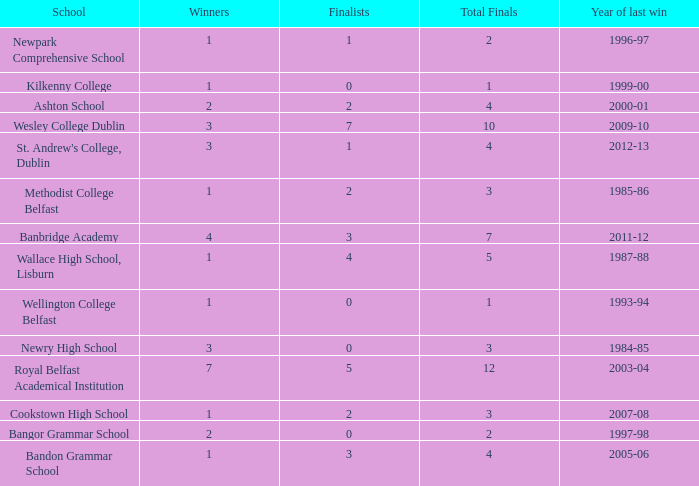I'm looking to parse the entire table for insights. Could you assist me with that? {'header': ['School', 'Winners', 'Finalists', 'Total Finals', 'Year of last win'], 'rows': [['Newpark Comprehensive School', '1', '1', '2', '1996-97'], ['Kilkenny College', '1', '0', '1', '1999-00'], ['Ashton School', '2', '2', '4', '2000-01'], ['Wesley College Dublin', '3', '7', '10', '2009-10'], ["St. Andrew's College, Dublin", '3', '1', '4', '2012-13'], ['Methodist College Belfast', '1', '2', '3', '1985-86'], ['Banbridge Academy', '4', '3', '7', '2011-12'], ['Wallace High School, Lisburn', '1', '4', '5', '1987-88'], ['Wellington College Belfast', '1', '0', '1', '1993-94'], ['Newry High School', '3', '0', '3', '1984-85'], ['Royal Belfast Academical Institution', '7', '5', '12', '2003-04'], ['Cookstown High School', '1', '2', '3', '2007-08'], ['Bangor Grammar School', '2', '0', '2', '1997-98'], ['Bandon Grammar School', '1', '3', '4', '2005-06']]} What are the names that had a finalist score of 2? Ashton School, Cookstown High School, Methodist College Belfast. 